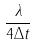Convert formula to latex. <formula><loc_0><loc_0><loc_500><loc_500>\frac { \lambda } { 4 \Delta t }</formula> 